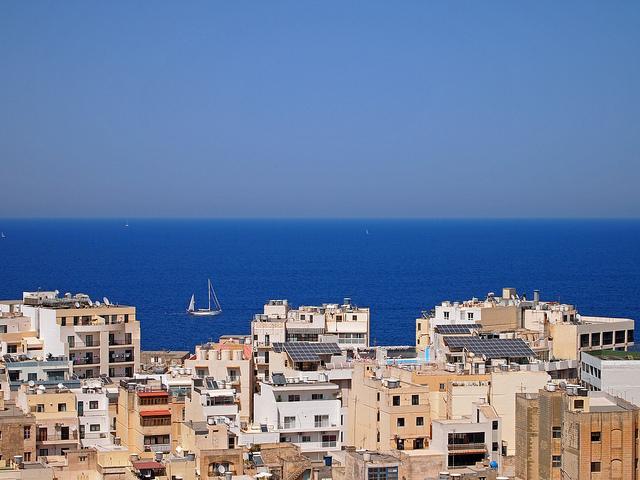Is this considered a bird's eye view?
Write a very short answer. Yes. Is the sea calm?
Short answer required. Yes. What is the weather like?
Be succinct. Clear. Are there clouds in the sky?
Be succinct. No. What is overlooking the body of water?
Short answer required. City. 